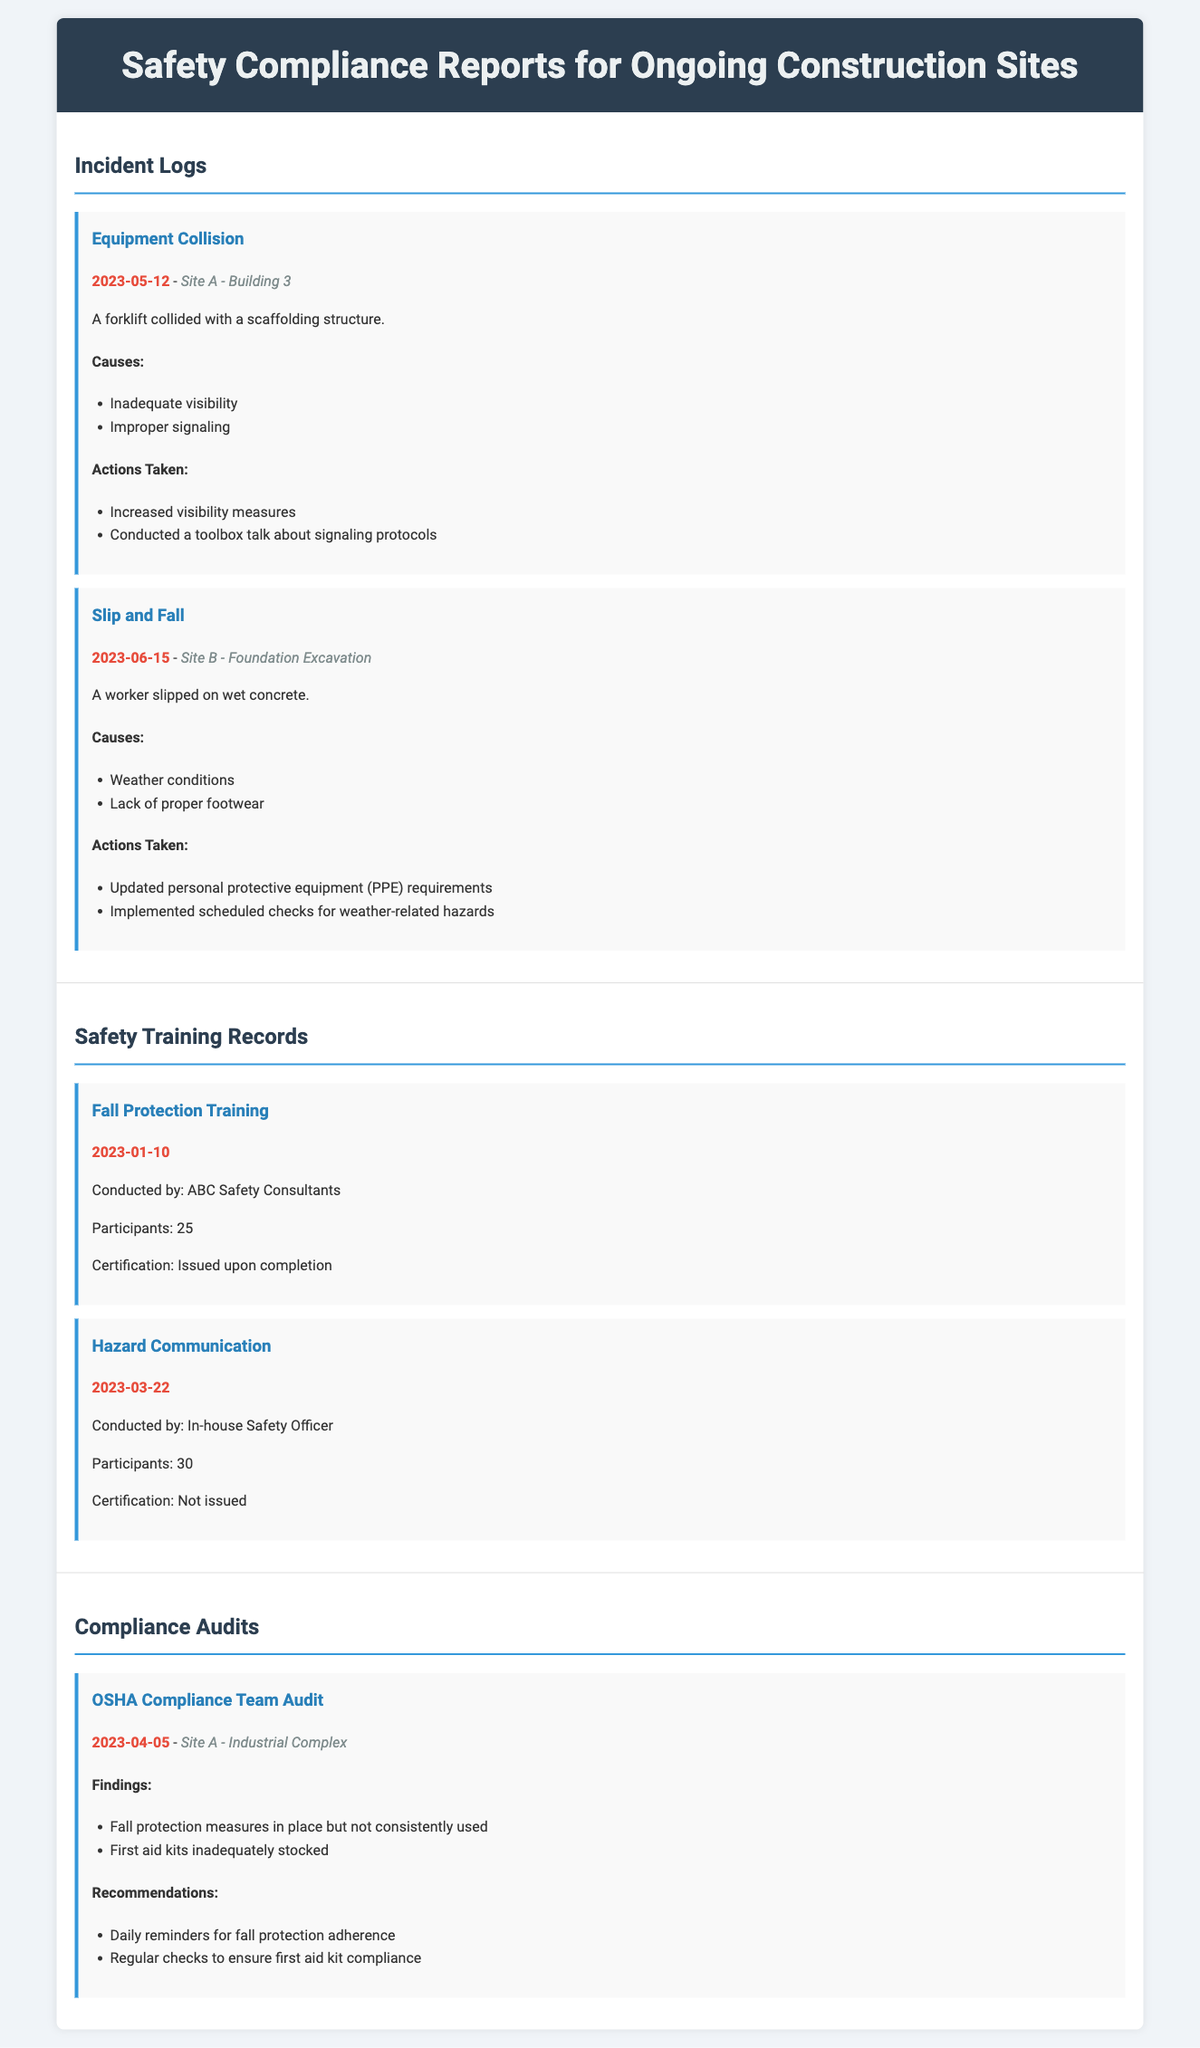What type of incident was recorded on 2023-05-12? The document lists an incident regarding a collision involving equipment on that date.
Answer: Equipment Collision What specific location did the slip and fall incident occur? The location for the slip and fall incident is detailed in the document.
Answer: Site B - Foundation Excavation How many participants attended the Fall Protection Training conducted on 2023-01-10? The document specifies the number of participants for this training session.
Answer: 25 What was a key recommendation from the OSHA Compliance Team Audit? The document mentions specific recommendations resulting from the compliance audit.
Answer: Daily reminders for fall protection adherence What caused the worker to slip in the incident on 2023-06-15? The document lists reasons that contributed to the slip and fall incident.
Answer: Weather conditions When was the Hazard Communication training conducted? The document provides the date of the Hazard Communication training session.
Answer: 2023-03-22 What actions were taken after the equipment collision incident? The document outlines actions taken in response to this incident.
Answer: Increased visibility measures How many incidents are listed under Incident Logs? The document provides a count of incidents detailed in this section.
Answer: 2 